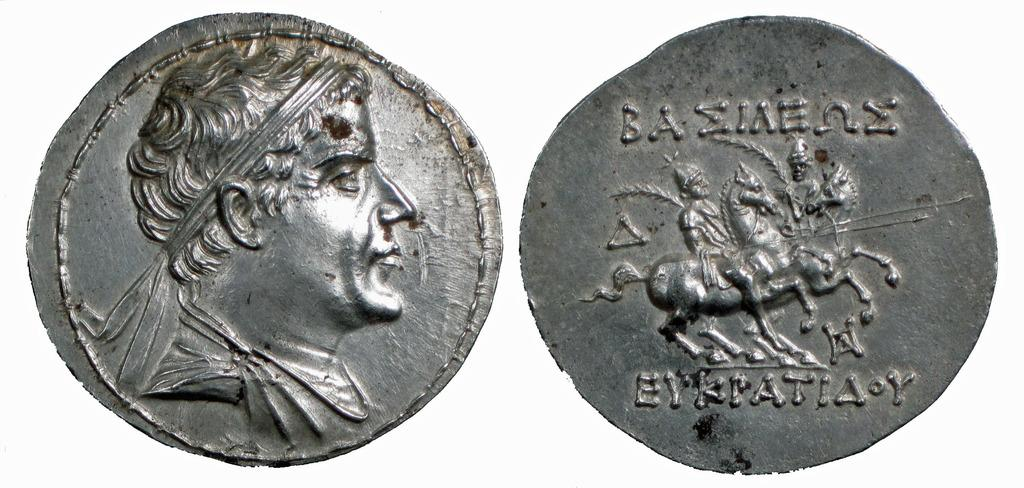<image>
Give a short and clear explanation of the subsequent image. Two very old looking silver coins, the one on the right has a word which begins with the letters BA on it. 